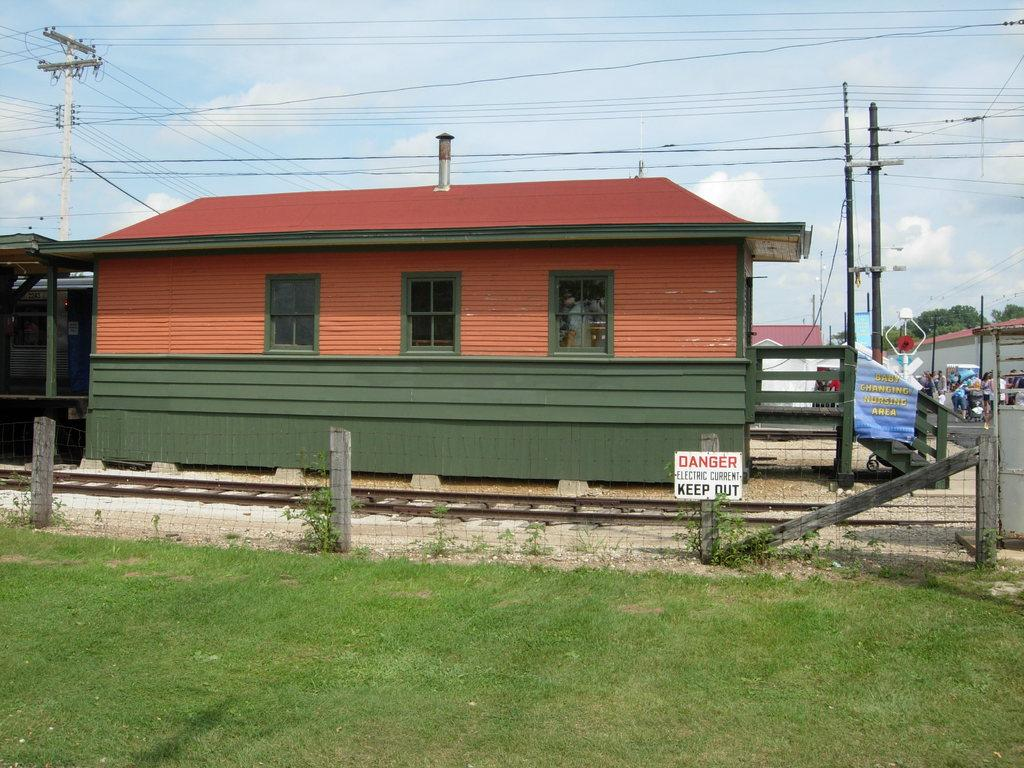What type of structures can be seen in the image? There are buildings in the image. What else can be seen in the image besides buildings? Electric poles, cables, people, trees, plants, stairs, grass, and a railway track are visible in the image. Can you describe the vegetation present in the image? Trees and plants are present in the image. What is the purpose of the name board in the image? The name board in the image is likely used for identification or direction. What type of grain is being harvested by the people in the image? There are no people harvesting grain in the image; the people are simply present in the scene. What rhythm is being played by the trees in the image? Trees do not produce or play rhythms; they are a type of vegetation. 